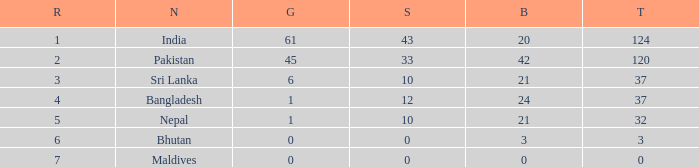How much Silver has a Rank of 7? 1.0. 